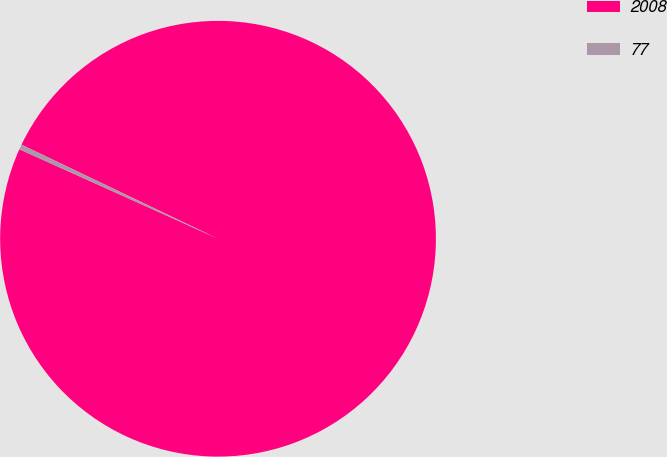Convert chart. <chart><loc_0><loc_0><loc_500><loc_500><pie_chart><fcel>2008<fcel>77<nl><fcel>99.63%<fcel>0.37%<nl></chart> 